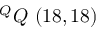Convert formula to latex. <formula><loc_0><loc_0><loc_500><loc_500>^ { Q } Q \ ( 1 8 , 1 8 )</formula> 